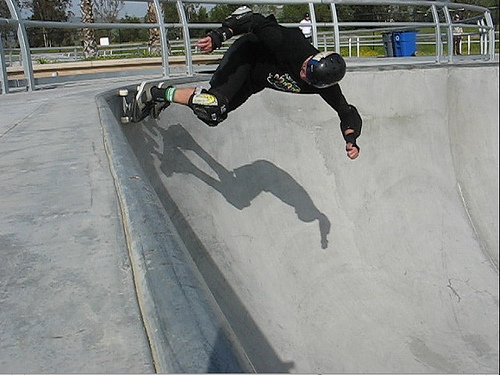<image>What trick is he doing? I don't know what trick he is doing. It could be a jump, a slide or skate on rail. What trick is he doing? I don't know what trick he is doing. It can be any of ['going around corner', 'jump', 'alpha flip', 'on rail', 'rim skate', 'half pipe', 'carving', 'slide']. 